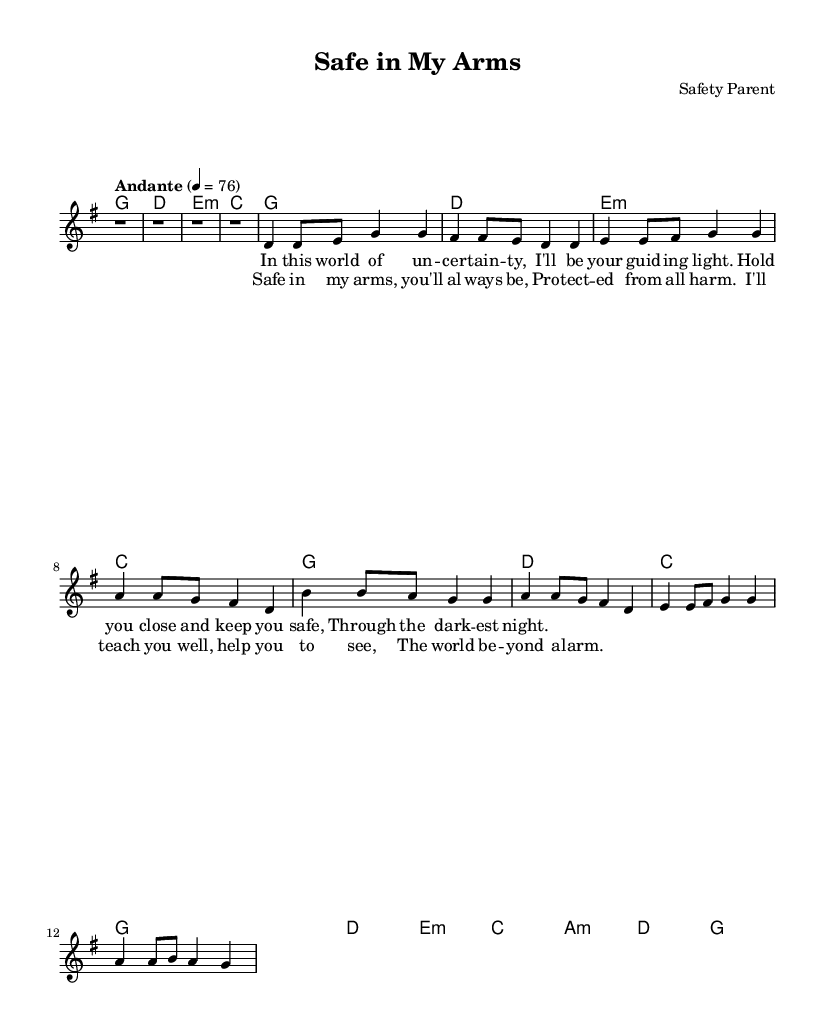What is the key signature of this music? The key signature is G major, indicated by one sharp (F#). This is shown at the beginning of the score.
Answer: G major What is the time signature of this music? The time signature is 4/4, which means there are four beats in each measure and the quarter note receives one beat. This is found at the start of the score.
Answer: 4/4 What is the tempo marking for this piece? The tempo marking is "Andante," which indicates a moderately slow tempo. This is expressed above the staff where the tempo is indicated.
Answer: Andante How many measures are in the chorus? The chorus consists of four measures, as indicated by the placement of the notes and the structure of the lyrics beneath them. By counting the measures in that section, we find it totals four.
Answer: 4 In which section does the lyric "Safe in my arms, you'll always be" appear? This lyric is part of the chorus, as identified by its placement in the score which aligns with the corresponding melody and harmonies.
Answer: Chorus What is the first chord in the piece? The first chord in the piece is G major, which is indicated by the chord name before the melody starts.
Answer: G What is the overall theme of the lyrics in this piece? The overall theme focuses on protection and nurturing, as the lyrics express the desire to keep a loved one safe and guide them through uncertainty. This can be inferred from the content of both verses and the chorus.
Answer: Protection and nurturing 